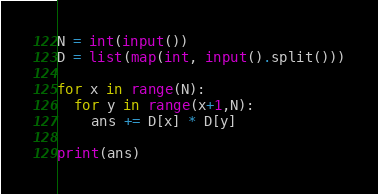<code> <loc_0><loc_0><loc_500><loc_500><_Python_>N = int(input())
D = list(map(int, input().split()))

for x in range(N):
  for y in range(x+1,N):
    ans += D[x] * D[y]

print(ans)

</code> 